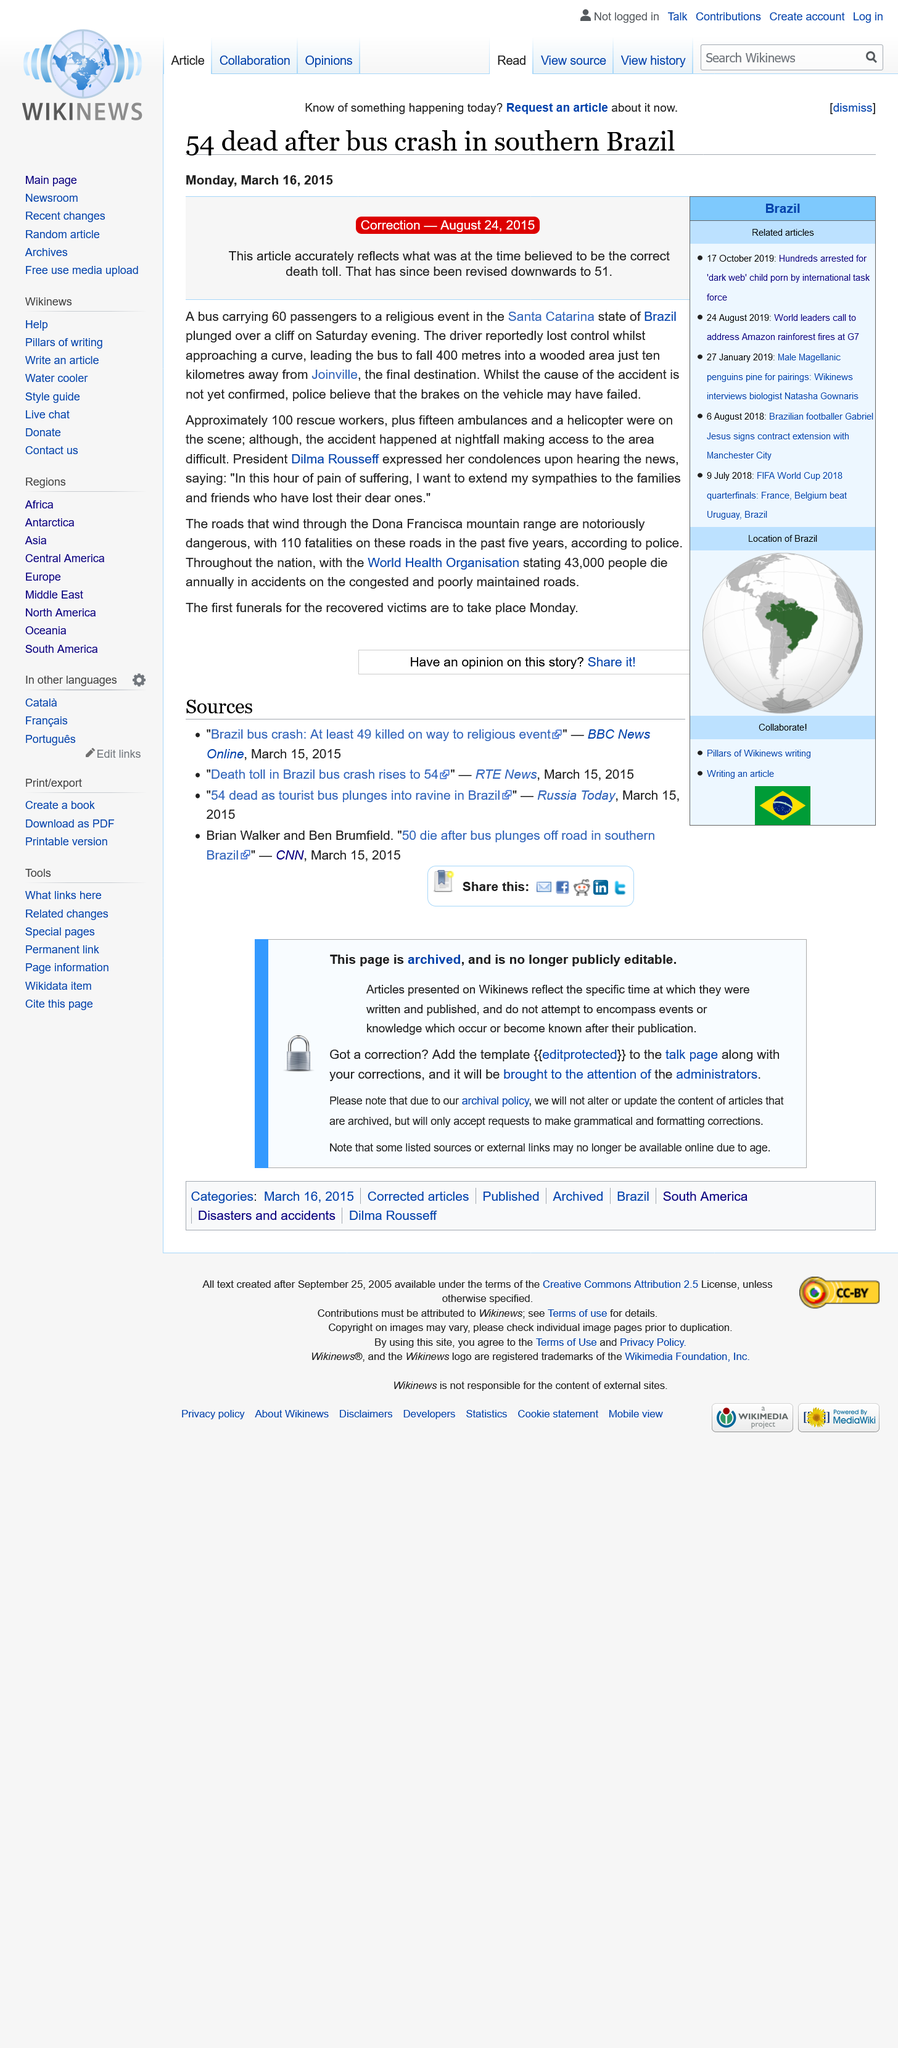Give some essential details in this illustration. Si se puede determinar cuántas personas estuvieron en el autobús que se estrelló? Se contaron 60 personas en el autobús que se estrelló. After the correction was applied, the death toll stood at 51. It is known that there were 100 rescue workers present at the scene. 